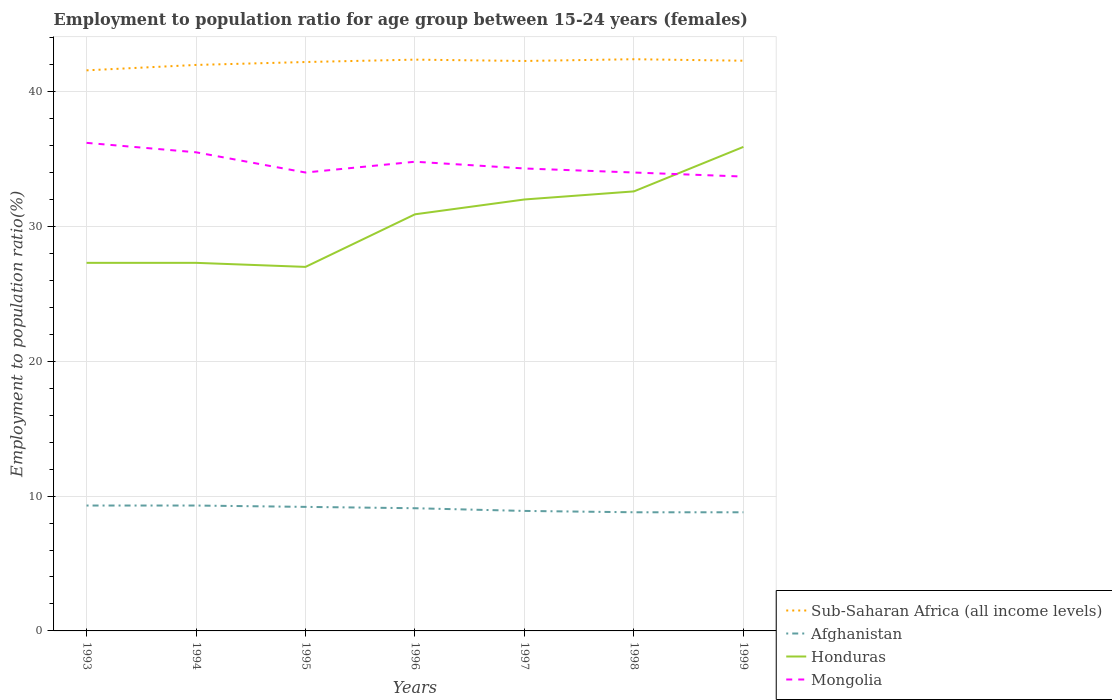How many different coloured lines are there?
Give a very brief answer. 4. Does the line corresponding to Afghanistan intersect with the line corresponding to Honduras?
Ensure brevity in your answer.  No. Is the number of lines equal to the number of legend labels?
Offer a very short reply. Yes. Across all years, what is the maximum employment to population ratio in Mongolia?
Offer a very short reply. 33.7. What is the total employment to population ratio in Mongolia in the graph?
Keep it short and to the point. 0.3. What is the difference between the highest and the lowest employment to population ratio in Honduras?
Ensure brevity in your answer.  4. Is the employment to population ratio in Sub-Saharan Africa (all income levels) strictly greater than the employment to population ratio in Mongolia over the years?
Offer a terse response. No. How many lines are there?
Give a very brief answer. 4. What is the difference between two consecutive major ticks on the Y-axis?
Ensure brevity in your answer.  10. Does the graph contain grids?
Your answer should be very brief. Yes. How are the legend labels stacked?
Your answer should be very brief. Vertical. What is the title of the graph?
Provide a short and direct response. Employment to population ratio for age group between 15-24 years (females). What is the Employment to population ratio(%) of Sub-Saharan Africa (all income levels) in 1993?
Your response must be concise. 41.58. What is the Employment to population ratio(%) of Afghanistan in 1993?
Offer a terse response. 9.3. What is the Employment to population ratio(%) of Honduras in 1993?
Keep it short and to the point. 27.3. What is the Employment to population ratio(%) of Mongolia in 1993?
Provide a short and direct response. 36.2. What is the Employment to population ratio(%) in Sub-Saharan Africa (all income levels) in 1994?
Provide a succinct answer. 41.98. What is the Employment to population ratio(%) in Afghanistan in 1994?
Offer a terse response. 9.3. What is the Employment to population ratio(%) of Honduras in 1994?
Make the answer very short. 27.3. What is the Employment to population ratio(%) in Mongolia in 1994?
Your answer should be compact. 35.5. What is the Employment to population ratio(%) of Sub-Saharan Africa (all income levels) in 1995?
Provide a succinct answer. 42.2. What is the Employment to population ratio(%) of Afghanistan in 1995?
Your answer should be very brief. 9.2. What is the Employment to population ratio(%) of Sub-Saharan Africa (all income levels) in 1996?
Provide a short and direct response. 42.37. What is the Employment to population ratio(%) in Afghanistan in 1996?
Offer a terse response. 9.1. What is the Employment to population ratio(%) in Honduras in 1996?
Your answer should be compact. 30.9. What is the Employment to population ratio(%) in Mongolia in 1996?
Keep it short and to the point. 34.8. What is the Employment to population ratio(%) of Sub-Saharan Africa (all income levels) in 1997?
Offer a terse response. 42.27. What is the Employment to population ratio(%) in Afghanistan in 1997?
Ensure brevity in your answer.  8.9. What is the Employment to population ratio(%) of Mongolia in 1997?
Make the answer very short. 34.3. What is the Employment to population ratio(%) in Sub-Saharan Africa (all income levels) in 1998?
Keep it short and to the point. 42.4. What is the Employment to population ratio(%) in Afghanistan in 1998?
Offer a terse response. 8.8. What is the Employment to population ratio(%) of Honduras in 1998?
Your answer should be compact. 32.6. What is the Employment to population ratio(%) of Sub-Saharan Africa (all income levels) in 1999?
Provide a succinct answer. 42.29. What is the Employment to population ratio(%) in Afghanistan in 1999?
Provide a short and direct response. 8.8. What is the Employment to population ratio(%) of Honduras in 1999?
Provide a succinct answer. 35.9. What is the Employment to population ratio(%) in Mongolia in 1999?
Make the answer very short. 33.7. Across all years, what is the maximum Employment to population ratio(%) in Sub-Saharan Africa (all income levels)?
Your answer should be very brief. 42.4. Across all years, what is the maximum Employment to population ratio(%) in Afghanistan?
Your answer should be compact. 9.3. Across all years, what is the maximum Employment to population ratio(%) in Honduras?
Give a very brief answer. 35.9. Across all years, what is the maximum Employment to population ratio(%) in Mongolia?
Ensure brevity in your answer.  36.2. Across all years, what is the minimum Employment to population ratio(%) of Sub-Saharan Africa (all income levels)?
Give a very brief answer. 41.58. Across all years, what is the minimum Employment to population ratio(%) of Afghanistan?
Make the answer very short. 8.8. Across all years, what is the minimum Employment to population ratio(%) in Honduras?
Provide a succinct answer. 27. Across all years, what is the minimum Employment to population ratio(%) of Mongolia?
Make the answer very short. 33.7. What is the total Employment to population ratio(%) in Sub-Saharan Africa (all income levels) in the graph?
Offer a terse response. 295.09. What is the total Employment to population ratio(%) of Afghanistan in the graph?
Provide a short and direct response. 63.4. What is the total Employment to population ratio(%) in Honduras in the graph?
Give a very brief answer. 213. What is the total Employment to population ratio(%) of Mongolia in the graph?
Give a very brief answer. 242.5. What is the difference between the Employment to population ratio(%) in Sub-Saharan Africa (all income levels) in 1993 and that in 1994?
Your answer should be very brief. -0.4. What is the difference between the Employment to population ratio(%) of Mongolia in 1993 and that in 1994?
Ensure brevity in your answer.  0.7. What is the difference between the Employment to population ratio(%) in Sub-Saharan Africa (all income levels) in 1993 and that in 1995?
Your response must be concise. -0.62. What is the difference between the Employment to population ratio(%) in Mongolia in 1993 and that in 1995?
Your answer should be compact. 2.2. What is the difference between the Employment to population ratio(%) of Sub-Saharan Africa (all income levels) in 1993 and that in 1996?
Ensure brevity in your answer.  -0.79. What is the difference between the Employment to population ratio(%) of Mongolia in 1993 and that in 1996?
Offer a terse response. 1.4. What is the difference between the Employment to population ratio(%) of Sub-Saharan Africa (all income levels) in 1993 and that in 1997?
Provide a short and direct response. -0.69. What is the difference between the Employment to population ratio(%) in Afghanistan in 1993 and that in 1997?
Make the answer very short. 0.4. What is the difference between the Employment to population ratio(%) in Honduras in 1993 and that in 1997?
Your answer should be very brief. -4.7. What is the difference between the Employment to population ratio(%) of Sub-Saharan Africa (all income levels) in 1993 and that in 1998?
Offer a very short reply. -0.82. What is the difference between the Employment to population ratio(%) in Honduras in 1993 and that in 1998?
Your response must be concise. -5.3. What is the difference between the Employment to population ratio(%) in Mongolia in 1993 and that in 1998?
Ensure brevity in your answer.  2.2. What is the difference between the Employment to population ratio(%) of Sub-Saharan Africa (all income levels) in 1993 and that in 1999?
Keep it short and to the point. -0.71. What is the difference between the Employment to population ratio(%) in Afghanistan in 1993 and that in 1999?
Your answer should be compact. 0.5. What is the difference between the Employment to population ratio(%) of Honduras in 1993 and that in 1999?
Your answer should be very brief. -8.6. What is the difference between the Employment to population ratio(%) in Sub-Saharan Africa (all income levels) in 1994 and that in 1995?
Offer a very short reply. -0.22. What is the difference between the Employment to population ratio(%) of Honduras in 1994 and that in 1995?
Offer a terse response. 0.3. What is the difference between the Employment to population ratio(%) in Sub-Saharan Africa (all income levels) in 1994 and that in 1996?
Provide a short and direct response. -0.39. What is the difference between the Employment to population ratio(%) in Sub-Saharan Africa (all income levels) in 1994 and that in 1997?
Ensure brevity in your answer.  -0.29. What is the difference between the Employment to population ratio(%) of Sub-Saharan Africa (all income levels) in 1994 and that in 1998?
Offer a terse response. -0.42. What is the difference between the Employment to population ratio(%) of Honduras in 1994 and that in 1998?
Your answer should be very brief. -5.3. What is the difference between the Employment to population ratio(%) of Mongolia in 1994 and that in 1998?
Provide a succinct answer. 1.5. What is the difference between the Employment to population ratio(%) in Sub-Saharan Africa (all income levels) in 1994 and that in 1999?
Give a very brief answer. -0.31. What is the difference between the Employment to population ratio(%) in Honduras in 1994 and that in 1999?
Your answer should be very brief. -8.6. What is the difference between the Employment to population ratio(%) of Sub-Saharan Africa (all income levels) in 1995 and that in 1996?
Give a very brief answer. -0.18. What is the difference between the Employment to population ratio(%) in Afghanistan in 1995 and that in 1996?
Provide a succinct answer. 0.1. What is the difference between the Employment to population ratio(%) of Sub-Saharan Africa (all income levels) in 1995 and that in 1997?
Your response must be concise. -0.08. What is the difference between the Employment to population ratio(%) of Afghanistan in 1995 and that in 1997?
Offer a terse response. 0.3. What is the difference between the Employment to population ratio(%) of Honduras in 1995 and that in 1997?
Ensure brevity in your answer.  -5. What is the difference between the Employment to population ratio(%) of Sub-Saharan Africa (all income levels) in 1995 and that in 1998?
Provide a succinct answer. -0.21. What is the difference between the Employment to population ratio(%) of Mongolia in 1995 and that in 1998?
Provide a short and direct response. 0. What is the difference between the Employment to population ratio(%) in Sub-Saharan Africa (all income levels) in 1995 and that in 1999?
Keep it short and to the point. -0.1. What is the difference between the Employment to population ratio(%) in Honduras in 1995 and that in 1999?
Your answer should be compact. -8.9. What is the difference between the Employment to population ratio(%) in Sub-Saharan Africa (all income levels) in 1996 and that in 1997?
Ensure brevity in your answer.  0.1. What is the difference between the Employment to population ratio(%) of Honduras in 1996 and that in 1997?
Your response must be concise. -1.1. What is the difference between the Employment to population ratio(%) in Mongolia in 1996 and that in 1997?
Ensure brevity in your answer.  0.5. What is the difference between the Employment to population ratio(%) in Sub-Saharan Africa (all income levels) in 1996 and that in 1998?
Provide a succinct answer. -0.03. What is the difference between the Employment to population ratio(%) in Honduras in 1996 and that in 1998?
Provide a succinct answer. -1.7. What is the difference between the Employment to population ratio(%) in Mongolia in 1996 and that in 1998?
Offer a very short reply. 0.8. What is the difference between the Employment to population ratio(%) of Sub-Saharan Africa (all income levels) in 1996 and that in 1999?
Provide a succinct answer. 0.08. What is the difference between the Employment to population ratio(%) in Mongolia in 1996 and that in 1999?
Ensure brevity in your answer.  1.1. What is the difference between the Employment to population ratio(%) in Sub-Saharan Africa (all income levels) in 1997 and that in 1998?
Provide a short and direct response. -0.13. What is the difference between the Employment to population ratio(%) in Afghanistan in 1997 and that in 1998?
Offer a terse response. 0.1. What is the difference between the Employment to population ratio(%) in Honduras in 1997 and that in 1998?
Your response must be concise. -0.6. What is the difference between the Employment to population ratio(%) in Mongolia in 1997 and that in 1998?
Offer a terse response. 0.3. What is the difference between the Employment to population ratio(%) in Sub-Saharan Africa (all income levels) in 1997 and that in 1999?
Offer a terse response. -0.02. What is the difference between the Employment to population ratio(%) in Sub-Saharan Africa (all income levels) in 1998 and that in 1999?
Offer a terse response. 0.11. What is the difference between the Employment to population ratio(%) of Afghanistan in 1998 and that in 1999?
Offer a terse response. 0. What is the difference between the Employment to population ratio(%) of Honduras in 1998 and that in 1999?
Make the answer very short. -3.3. What is the difference between the Employment to population ratio(%) in Mongolia in 1998 and that in 1999?
Provide a short and direct response. 0.3. What is the difference between the Employment to population ratio(%) of Sub-Saharan Africa (all income levels) in 1993 and the Employment to population ratio(%) of Afghanistan in 1994?
Make the answer very short. 32.28. What is the difference between the Employment to population ratio(%) in Sub-Saharan Africa (all income levels) in 1993 and the Employment to population ratio(%) in Honduras in 1994?
Your answer should be very brief. 14.28. What is the difference between the Employment to population ratio(%) of Sub-Saharan Africa (all income levels) in 1993 and the Employment to population ratio(%) of Mongolia in 1994?
Make the answer very short. 6.08. What is the difference between the Employment to population ratio(%) in Afghanistan in 1993 and the Employment to population ratio(%) in Mongolia in 1994?
Make the answer very short. -26.2. What is the difference between the Employment to population ratio(%) in Honduras in 1993 and the Employment to population ratio(%) in Mongolia in 1994?
Offer a very short reply. -8.2. What is the difference between the Employment to population ratio(%) in Sub-Saharan Africa (all income levels) in 1993 and the Employment to population ratio(%) in Afghanistan in 1995?
Ensure brevity in your answer.  32.38. What is the difference between the Employment to population ratio(%) in Sub-Saharan Africa (all income levels) in 1993 and the Employment to population ratio(%) in Honduras in 1995?
Offer a terse response. 14.58. What is the difference between the Employment to population ratio(%) of Sub-Saharan Africa (all income levels) in 1993 and the Employment to population ratio(%) of Mongolia in 1995?
Your answer should be compact. 7.58. What is the difference between the Employment to population ratio(%) in Afghanistan in 1993 and the Employment to population ratio(%) in Honduras in 1995?
Make the answer very short. -17.7. What is the difference between the Employment to population ratio(%) in Afghanistan in 1993 and the Employment to population ratio(%) in Mongolia in 1995?
Give a very brief answer. -24.7. What is the difference between the Employment to population ratio(%) of Honduras in 1993 and the Employment to population ratio(%) of Mongolia in 1995?
Give a very brief answer. -6.7. What is the difference between the Employment to population ratio(%) of Sub-Saharan Africa (all income levels) in 1993 and the Employment to population ratio(%) of Afghanistan in 1996?
Offer a terse response. 32.48. What is the difference between the Employment to population ratio(%) in Sub-Saharan Africa (all income levels) in 1993 and the Employment to population ratio(%) in Honduras in 1996?
Make the answer very short. 10.68. What is the difference between the Employment to population ratio(%) of Sub-Saharan Africa (all income levels) in 1993 and the Employment to population ratio(%) of Mongolia in 1996?
Ensure brevity in your answer.  6.78. What is the difference between the Employment to population ratio(%) in Afghanistan in 1993 and the Employment to population ratio(%) in Honduras in 1996?
Offer a terse response. -21.6. What is the difference between the Employment to population ratio(%) in Afghanistan in 1993 and the Employment to population ratio(%) in Mongolia in 1996?
Ensure brevity in your answer.  -25.5. What is the difference between the Employment to population ratio(%) in Sub-Saharan Africa (all income levels) in 1993 and the Employment to population ratio(%) in Afghanistan in 1997?
Ensure brevity in your answer.  32.68. What is the difference between the Employment to population ratio(%) in Sub-Saharan Africa (all income levels) in 1993 and the Employment to population ratio(%) in Honduras in 1997?
Provide a short and direct response. 9.58. What is the difference between the Employment to population ratio(%) in Sub-Saharan Africa (all income levels) in 1993 and the Employment to population ratio(%) in Mongolia in 1997?
Your response must be concise. 7.28. What is the difference between the Employment to population ratio(%) of Afghanistan in 1993 and the Employment to population ratio(%) of Honduras in 1997?
Offer a very short reply. -22.7. What is the difference between the Employment to population ratio(%) of Afghanistan in 1993 and the Employment to population ratio(%) of Mongolia in 1997?
Give a very brief answer. -25. What is the difference between the Employment to population ratio(%) of Honduras in 1993 and the Employment to population ratio(%) of Mongolia in 1997?
Offer a very short reply. -7. What is the difference between the Employment to population ratio(%) of Sub-Saharan Africa (all income levels) in 1993 and the Employment to population ratio(%) of Afghanistan in 1998?
Your response must be concise. 32.78. What is the difference between the Employment to population ratio(%) in Sub-Saharan Africa (all income levels) in 1993 and the Employment to population ratio(%) in Honduras in 1998?
Offer a very short reply. 8.98. What is the difference between the Employment to population ratio(%) of Sub-Saharan Africa (all income levels) in 1993 and the Employment to population ratio(%) of Mongolia in 1998?
Give a very brief answer. 7.58. What is the difference between the Employment to population ratio(%) in Afghanistan in 1993 and the Employment to population ratio(%) in Honduras in 1998?
Provide a succinct answer. -23.3. What is the difference between the Employment to population ratio(%) in Afghanistan in 1993 and the Employment to population ratio(%) in Mongolia in 1998?
Your answer should be very brief. -24.7. What is the difference between the Employment to population ratio(%) of Honduras in 1993 and the Employment to population ratio(%) of Mongolia in 1998?
Offer a very short reply. -6.7. What is the difference between the Employment to population ratio(%) of Sub-Saharan Africa (all income levels) in 1993 and the Employment to population ratio(%) of Afghanistan in 1999?
Offer a very short reply. 32.78. What is the difference between the Employment to population ratio(%) in Sub-Saharan Africa (all income levels) in 1993 and the Employment to population ratio(%) in Honduras in 1999?
Make the answer very short. 5.68. What is the difference between the Employment to population ratio(%) of Sub-Saharan Africa (all income levels) in 1993 and the Employment to population ratio(%) of Mongolia in 1999?
Offer a very short reply. 7.88. What is the difference between the Employment to population ratio(%) of Afghanistan in 1993 and the Employment to population ratio(%) of Honduras in 1999?
Your answer should be compact. -26.6. What is the difference between the Employment to population ratio(%) of Afghanistan in 1993 and the Employment to population ratio(%) of Mongolia in 1999?
Offer a terse response. -24.4. What is the difference between the Employment to population ratio(%) of Sub-Saharan Africa (all income levels) in 1994 and the Employment to population ratio(%) of Afghanistan in 1995?
Offer a very short reply. 32.78. What is the difference between the Employment to population ratio(%) of Sub-Saharan Africa (all income levels) in 1994 and the Employment to population ratio(%) of Honduras in 1995?
Give a very brief answer. 14.98. What is the difference between the Employment to population ratio(%) in Sub-Saharan Africa (all income levels) in 1994 and the Employment to population ratio(%) in Mongolia in 1995?
Provide a succinct answer. 7.98. What is the difference between the Employment to population ratio(%) of Afghanistan in 1994 and the Employment to population ratio(%) of Honduras in 1995?
Your response must be concise. -17.7. What is the difference between the Employment to population ratio(%) of Afghanistan in 1994 and the Employment to population ratio(%) of Mongolia in 1995?
Ensure brevity in your answer.  -24.7. What is the difference between the Employment to population ratio(%) of Sub-Saharan Africa (all income levels) in 1994 and the Employment to population ratio(%) of Afghanistan in 1996?
Provide a succinct answer. 32.88. What is the difference between the Employment to population ratio(%) of Sub-Saharan Africa (all income levels) in 1994 and the Employment to population ratio(%) of Honduras in 1996?
Your response must be concise. 11.08. What is the difference between the Employment to population ratio(%) in Sub-Saharan Africa (all income levels) in 1994 and the Employment to population ratio(%) in Mongolia in 1996?
Offer a very short reply. 7.18. What is the difference between the Employment to population ratio(%) of Afghanistan in 1994 and the Employment to population ratio(%) of Honduras in 1996?
Your response must be concise. -21.6. What is the difference between the Employment to population ratio(%) of Afghanistan in 1994 and the Employment to population ratio(%) of Mongolia in 1996?
Offer a very short reply. -25.5. What is the difference between the Employment to population ratio(%) in Honduras in 1994 and the Employment to population ratio(%) in Mongolia in 1996?
Provide a succinct answer. -7.5. What is the difference between the Employment to population ratio(%) of Sub-Saharan Africa (all income levels) in 1994 and the Employment to population ratio(%) of Afghanistan in 1997?
Make the answer very short. 33.08. What is the difference between the Employment to population ratio(%) of Sub-Saharan Africa (all income levels) in 1994 and the Employment to population ratio(%) of Honduras in 1997?
Offer a terse response. 9.98. What is the difference between the Employment to population ratio(%) of Sub-Saharan Africa (all income levels) in 1994 and the Employment to population ratio(%) of Mongolia in 1997?
Ensure brevity in your answer.  7.68. What is the difference between the Employment to population ratio(%) in Afghanistan in 1994 and the Employment to population ratio(%) in Honduras in 1997?
Your answer should be very brief. -22.7. What is the difference between the Employment to population ratio(%) in Afghanistan in 1994 and the Employment to population ratio(%) in Mongolia in 1997?
Provide a succinct answer. -25. What is the difference between the Employment to population ratio(%) of Honduras in 1994 and the Employment to population ratio(%) of Mongolia in 1997?
Your response must be concise. -7. What is the difference between the Employment to population ratio(%) in Sub-Saharan Africa (all income levels) in 1994 and the Employment to population ratio(%) in Afghanistan in 1998?
Your response must be concise. 33.18. What is the difference between the Employment to population ratio(%) of Sub-Saharan Africa (all income levels) in 1994 and the Employment to population ratio(%) of Honduras in 1998?
Your answer should be compact. 9.38. What is the difference between the Employment to population ratio(%) in Sub-Saharan Africa (all income levels) in 1994 and the Employment to population ratio(%) in Mongolia in 1998?
Your response must be concise. 7.98. What is the difference between the Employment to population ratio(%) of Afghanistan in 1994 and the Employment to population ratio(%) of Honduras in 1998?
Your answer should be compact. -23.3. What is the difference between the Employment to population ratio(%) of Afghanistan in 1994 and the Employment to population ratio(%) of Mongolia in 1998?
Provide a short and direct response. -24.7. What is the difference between the Employment to population ratio(%) of Honduras in 1994 and the Employment to population ratio(%) of Mongolia in 1998?
Provide a short and direct response. -6.7. What is the difference between the Employment to population ratio(%) of Sub-Saharan Africa (all income levels) in 1994 and the Employment to population ratio(%) of Afghanistan in 1999?
Make the answer very short. 33.18. What is the difference between the Employment to population ratio(%) of Sub-Saharan Africa (all income levels) in 1994 and the Employment to population ratio(%) of Honduras in 1999?
Ensure brevity in your answer.  6.08. What is the difference between the Employment to population ratio(%) in Sub-Saharan Africa (all income levels) in 1994 and the Employment to population ratio(%) in Mongolia in 1999?
Your response must be concise. 8.28. What is the difference between the Employment to population ratio(%) of Afghanistan in 1994 and the Employment to population ratio(%) of Honduras in 1999?
Keep it short and to the point. -26.6. What is the difference between the Employment to population ratio(%) of Afghanistan in 1994 and the Employment to population ratio(%) of Mongolia in 1999?
Provide a short and direct response. -24.4. What is the difference between the Employment to population ratio(%) of Honduras in 1994 and the Employment to population ratio(%) of Mongolia in 1999?
Offer a very short reply. -6.4. What is the difference between the Employment to population ratio(%) of Sub-Saharan Africa (all income levels) in 1995 and the Employment to population ratio(%) of Afghanistan in 1996?
Offer a very short reply. 33.1. What is the difference between the Employment to population ratio(%) in Sub-Saharan Africa (all income levels) in 1995 and the Employment to population ratio(%) in Honduras in 1996?
Your answer should be compact. 11.3. What is the difference between the Employment to population ratio(%) in Sub-Saharan Africa (all income levels) in 1995 and the Employment to population ratio(%) in Mongolia in 1996?
Give a very brief answer. 7.4. What is the difference between the Employment to population ratio(%) of Afghanistan in 1995 and the Employment to population ratio(%) of Honduras in 1996?
Your response must be concise. -21.7. What is the difference between the Employment to population ratio(%) of Afghanistan in 1995 and the Employment to population ratio(%) of Mongolia in 1996?
Provide a succinct answer. -25.6. What is the difference between the Employment to population ratio(%) in Sub-Saharan Africa (all income levels) in 1995 and the Employment to population ratio(%) in Afghanistan in 1997?
Provide a succinct answer. 33.3. What is the difference between the Employment to population ratio(%) in Sub-Saharan Africa (all income levels) in 1995 and the Employment to population ratio(%) in Honduras in 1997?
Ensure brevity in your answer.  10.2. What is the difference between the Employment to population ratio(%) of Sub-Saharan Africa (all income levels) in 1995 and the Employment to population ratio(%) of Mongolia in 1997?
Offer a very short reply. 7.9. What is the difference between the Employment to population ratio(%) in Afghanistan in 1995 and the Employment to population ratio(%) in Honduras in 1997?
Make the answer very short. -22.8. What is the difference between the Employment to population ratio(%) in Afghanistan in 1995 and the Employment to population ratio(%) in Mongolia in 1997?
Provide a succinct answer. -25.1. What is the difference between the Employment to population ratio(%) in Sub-Saharan Africa (all income levels) in 1995 and the Employment to population ratio(%) in Afghanistan in 1998?
Give a very brief answer. 33.4. What is the difference between the Employment to population ratio(%) in Sub-Saharan Africa (all income levels) in 1995 and the Employment to population ratio(%) in Honduras in 1998?
Your answer should be compact. 9.6. What is the difference between the Employment to population ratio(%) in Sub-Saharan Africa (all income levels) in 1995 and the Employment to population ratio(%) in Mongolia in 1998?
Provide a short and direct response. 8.2. What is the difference between the Employment to population ratio(%) in Afghanistan in 1995 and the Employment to population ratio(%) in Honduras in 1998?
Offer a terse response. -23.4. What is the difference between the Employment to population ratio(%) in Afghanistan in 1995 and the Employment to population ratio(%) in Mongolia in 1998?
Make the answer very short. -24.8. What is the difference between the Employment to population ratio(%) in Sub-Saharan Africa (all income levels) in 1995 and the Employment to population ratio(%) in Afghanistan in 1999?
Your answer should be compact. 33.4. What is the difference between the Employment to population ratio(%) of Sub-Saharan Africa (all income levels) in 1995 and the Employment to population ratio(%) of Honduras in 1999?
Provide a short and direct response. 6.3. What is the difference between the Employment to population ratio(%) of Sub-Saharan Africa (all income levels) in 1995 and the Employment to population ratio(%) of Mongolia in 1999?
Offer a terse response. 8.5. What is the difference between the Employment to population ratio(%) in Afghanistan in 1995 and the Employment to population ratio(%) in Honduras in 1999?
Your answer should be very brief. -26.7. What is the difference between the Employment to population ratio(%) in Afghanistan in 1995 and the Employment to population ratio(%) in Mongolia in 1999?
Your answer should be very brief. -24.5. What is the difference between the Employment to population ratio(%) in Honduras in 1995 and the Employment to population ratio(%) in Mongolia in 1999?
Your response must be concise. -6.7. What is the difference between the Employment to population ratio(%) in Sub-Saharan Africa (all income levels) in 1996 and the Employment to population ratio(%) in Afghanistan in 1997?
Your answer should be very brief. 33.47. What is the difference between the Employment to population ratio(%) of Sub-Saharan Africa (all income levels) in 1996 and the Employment to population ratio(%) of Honduras in 1997?
Keep it short and to the point. 10.37. What is the difference between the Employment to population ratio(%) in Sub-Saharan Africa (all income levels) in 1996 and the Employment to population ratio(%) in Mongolia in 1997?
Ensure brevity in your answer.  8.07. What is the difference between the Employment to population ratio(%) in Afghanistan in 1996 and the Employment to population ratio(%) in Honduras in 1997?
Your answer should be very brief. -22.9. What is the difference between the Employment to population ratio(%) of Afghanistan in 1996 and the Employment to population ratio(%) of Mongolia in 1997?
Your answer should be compact. -25.2. What is the difference between the Employment to population ratio(%) in Sub-Saharan Africa (all income levels) in 1996 and the Employment to population ratio(%) in Afghanistan in 1998?
Offer a very short reply. 33.57. What is the difference between the Employment to population ratio(%) in Sub-Saharan Africa (all income levels) in 1996 and the Employment to population ratio(%) in Honduras in 1998?
Your response must be concise. 9.77. What is the difference between the Employment to population ratio(%) in Sub-Saharan Africa (all income levels) in 1996 and the Employment to population ratio(%) in Mongolia in 1998?
Your answer should be very brief. 8.37. What is the difference between the Employment to population ratio(%) in Afghanistan in 1996 and the Employment to population ratio(%) in Honduras in 1998?
Your answer should be compact. -23.5. What is the difference between the Employment to population ratio(%) in Afghanistan in 1996 and the Employment to population ratio(%) in Mongolia in 1998?
Your response must be concise. -24.9. What is the difference between the Employment to population ratio(%) in Sub-Saharan Africa (all income levels) in 1996 and the Employment to population ratio(%) in Afghanistan in 1999?
Your response must be concise. 33.57. What is the difference between the Employment to population ratio(%) in Sub-Saharan Africa (all income levels) in 1996 and the Employment to population ratio(%) in Honduras in 1999?
Your response must be concise. 6.47. What is the difference between the Employment to population ratio(%) in Sub-Saharan Africa (all income levels) in 1996 and the Employment to population ratio(%) in Mongolia in 1999?
Keep it short and to the point. 8.67. What is the difference between the Employment to population ratio(%) of Afghanistan in 1996 and the Employment to population ratio(%) of Honduras in 1999?
Your response must be concise. -26.8. What is the difference between the Employment to population ratio(%) in Afghanistan in 1996 and the Employment to population ratio(%) in Mongolia in 1999?
Your answer should be very brief. -24.6. What is the difference between the Employment to population ratio(%) of Sub-Saharan Africa (all income levels) in 1997 and the Employment to population ratio(%) of Afghanistan in 1998?
Offer a terse response. 33.47. What is the difference between the Employment to population ratio(%) in Sub-Saharan Africa (all income levels) in 1997 and the Employment to population ratio(%) in Honduras in 1998?
Offer a very short reply. 9.67. What is the difference between the Employment to population ratio(%) in Sub-Saharan Africa (all income levels) in 1997 and the Employment to population ratio(%) in Mongolia in 1998?
Make the answer very short. 8.27. What is the difference between the Employment to population ratio(%) in Afghanistan in 1997 and the Employment to population ratio(%) in Honduras in 1998?
Provide a succinct answer. -23.7. What is the difference between the Employment to population ratio(%) in Afghanistan in 1997 and the Employment to population ratio(%) in Mongolia in 1998?
Your response must be concise. -25.1. What is the difference between the Employment to population ratio(%) in Honduras in 1997 and the Employment to population ratio(%) in Mongolia in 1998?
Make the answer very short. -2. What is the difference between the Employment to population ratio(%) in Sub-Saharan Africa (all income levels) in 1997 and the Employment to population ratio(%) in Afghanistan in 1999?
Provide a succinct answer. 33.47. What is the difference between the Employment to population ratio(%) of Sub-Saharan Africa (all income levels) in 1997 and the Employment to population ratio(%) of Honduras in 1999?
Your answer should be compact. 6.37. What is the difference between the Employment to population ratio(%) of Sub-Saharan Africa (all income levels) in 1997 and the Employment to population ratio(%) of Mongolia in 1999?
Give a very brief answer. 8.57. What is the difference between the Employment to population ratio(%) of Afghanistan in 1997 and the Employment to population ratio(%) of Mongolia in 1999?
Your answer should be very brief. -24.8. What is the difference between the Employment to population ratio(%) in Sub-Saharan Africa (all income levels) in 1998 and the Employment to population ratio(%) in Afghanistan in 1999?
Provide a short and direct response. 33.6. What is the difference between the Employment to population ratio(%) of Sub-Saharan Africa (all income levels) in 1998 and the Employment to population ratio(%) of Honduras in 1999?
Your response must be concise. 6.5. What is the difference between the Employment to population ratio(%) of Sub-Saharan Africa (all income levels) in 1998 and the Employment to population ratio(%) of Mongolia in 1999?
Make the answer very short. 8.7. What is the difference between the Employment to population ratio(%) of Afghanistan in 1998 and the Employment to population ratio(%) of Honduras in 1999?
Your answer should be compact. -27.1. What is the difference between the Employment to population ratio(%) in Afghanistan in 1998 and the Employment to population ratio(%) in Mongolia in 1999?
Provide a succinct answer. -24.9. What is the difference between the Employment to population ratio(%) in Honduras in 1998 and the Employment to population ratio(%) in Mongolia in 1999?
Give a very brief answer. -1.1. What is the average Employment to population ratio(%) of Sub-Saharan Africa (all income levels) per year?
Make the answer very short. 42.16. What is the average Employment to population ratio(%) of Afghanistan per year?
Your response must be concise. 9.06. What is the average Employment to population ratio(%) of Honduras per year?
Ensure brevity in your answer.  30.43. What is the average Employment to population ratio(%) in Mongolia per year?
Your answer should be compact. 34.64. In the year 1993, what is the difference between the Employment to population ratio(%) in Sub-Saharan Africa (all income levels) and Employment to population ratio(%) in Afghanistan?
Make the answer very short. 32.28. In the year 1993, what is the difference between the Employment to population ratio(%) of Sub-Saharan Africa (all income levels) and Employment to population ratio(%) of Honduras?
Your response must be concise. 14.28. In the year 1993, what is the difference between the Employment to population ratio(%) in Sub-Saharan Africa (all income levels) and Employment to population ratio(%) in Mongolia?
Your answer should be very brief. 5.38. In the year 1993, what is the difference between the Employment to population ratio(%) of Afghanistan and Employment to population ratio(%) of Mongolia?
Offer a very short reply. -26.9. In the year 1994, what is the difference between the Employment to population ratio(%) of Sub-Saharan Africa (all income levels) and Employment to population ratio(%) of Afghanistan?
Keep it short and to the point. 32.68. In the year 1994, what is the difference between the Employment to population ratio(%) in Sub-Saharan Africa (all income levels) and Employment to population ratio(%) in Honduras?
Ensure brevity in your answer.  14.68. In the year 1994, what is the difference between the Employment to population ratio(%) in Sub-Saharan Africa (all income levels) and Employment to population ratio(%) in Mongolia?
Ensure brevity in your answer.  6.48. In the year 1994, what is the difference between the Employment to population ratio(%) in Afghanistan and Employment to population ratio(%) in Honduras?
Ensure brevity in your answer.  -18. In the year 1994, what is the difference between the Employment to population ratio(%) of Afghanistan and Employment to population ratio(%) of Mongolia?
Offer a very short reply. -26.2. In the year 1994, what is the difference between the Employment to population ratio(%) in Honduras and Employment to population ratio(%) in Mongolia?
Offer a terse response. -8.2. In the year 1995, what is the difference between the Employment to population ratio(%) in Sub-Saharan Africa (all income levels) and Employment to population ratio(%) in Afghanistan?
Your answer should be compact. 33. In the year 1995, what is the difference between the Employment to population ratio(%) of Sub-Saharan Africa (all income levels) and Employment to population ratio(%) of Honduras?
Give a very brief answer. 15.2. In the year 1995, what is the difference between the Employment to population ratio(%) in Sub-Saharan Africa (all income levels) and Employment to population ratio(%) in Mongolia?
Your answer should be compact. 8.2. In the year 1995, what is the difference between the Employment to population ratio(%) in Afghanistan and Employment to population ratio(%) in Honduras?
Your answer should be very brief. -17.8. In the year 1995, what is the difference between the Employment to population ratio(%) in Afghanistan and Employment to population ratio(%) in Mongolia?
Provide a short and direct response. -24.8. In the year 1996, what is the difference between the Employment to population ratio(%) in Sub-Saharan Africa (all income levels) and Employment to population ratio(%) in Afghanistan?
Ensure brevity in your answer.  33.27. In the year 1996, what is the difference between the Employment to population ratio(%) of Sub-Saharan Africa (all income levels) and Employment to population ratio(%) of Honduras?
Give a very brief answer. 11.47. In the year 1996, what is the difference between the Employment to population ratio(%) of Sub-Saharan Africa (all income levels) and Employment to population ratio(%) of Mongolia?
Give a very brief answer. 7.57. In the year 1996, what is the difference between the Employment to population ratio(%) in Afghanistan and Employment to population ratio(%) in Honduras?
Your response must be concise. -21.8. In the year 1996, what is the difference between the Employment to population ratio(%) of Afghanistan and Employment to population ratio(%) of Mongolia?
Your answer should be compact. -25.7. In the year 1997, what is the difference between the Employment to population ratio(%) in Sub-Saharan Africa (all income levels) and Employment to population ratio(%) in Afghanistan?
Provide a succinct answer. 33.37. In the year 1997, what is the difference between the Employment to population ratio(%) in Sub-Saharan Africa (all income levels) and Employment to population ratio(%) in Honduras?
Keep it short and to the point. 10.27. In the year 1997, what is the difference between the Employment to population ratio(%) of Sub-Saharan Africa (all income levels) and Employment to population ratio(%) of Mongolia?
Give a very brief answer. 7.97. In the year 1997, what is the difference between the Employment to population ratio(%) of Afghanistan and Employment to population ratio(%) of Honduras?
Your response must be concise. -23.1. In the year 1997, what is the difference between the Employment to population ratio(%) in Afghanistan and Employment to population ratio(%) in Mongolia?
Offer a very short reply. -25.4. In the year 1997, what is the difference between the Employment to population ratio(%) of Honduras and Employment to population ratio(%) of Mongolia?
Your answer should be compact. -2.3. In the year 1998, what is the difference between the Employment to population ratio(%) in Sub-Saharan Africa (all income levels) and Employment to population ratio(%) in Afghanistan?
Give a very brief answer. 33.6. In the year 1998, what is the difference between the Employment to population ratio(%) of Sub-Saharan Africa (all income levels) and Employment to population ratio(%) of Honduras?
Make the answer very short. 9.8. In the year 1998, what is the difference between the Employment to population ratio(%) in Sub-Saharan Africa (all income levels) and Employment to population ratio(%) in Mongolia?
Your answer should be very brief. 8.4. In the year 1998, what is the difference between the Employment to population ratio(%) of Afghanistan and Employment to population ratio(%) of Honduras?
Your answer should be compact. -23.8. In the year 1998, what is the difference between the Employment to population ratio(%) in Afghanistan and Employment to population ratio(%) in Mongolia?
Ensure brevity in your answer.  -25.2. In the year 1998, what is the difference between the Employment to population ratio(%) in Honduras and Employment to population ratio(%) in Mongolia?
Keep it short and to the point. -1.4. In the year 1999, what is the difference between the Employment to population ratio(%) in Sub-Saharan Africa (all income levels) and Employment to population ratio(%) in Afghanistan?
Your answer should be compact. 33.49. In the year 1999, what is the difference between the Employment to population ratio(%) of Sub-Saharan Africa (all income levels) and Employment to population ratio(%) of Honduras?
Ensure brevity in your answer.  6.39. In the year 1999, what is the difference between the Employment to population ratio(%) in Sub-Saharan Africa (all income levels) and Employment to population ratio(%) in Mongolia?
Give a very brief answer. 8.59. In the year 1999, what is the difference between the Employment to population ratio(%) in Afghanistan and Employment to population ratio(%) in Honduras?
Your response must be concise. -27.1. In the year 1999, what is the difference between the Employment to population ratio(%) of Afghanistan and Employment to population ratio(%) of Mongolia?
Ensure brevity in your answer.  -24.9. In the year 1999, what is the difference between the Employment to population ratio(%) in Honduras and Employment to population ratio(%) in Mongolia?
Your answer should be compact. 2.2. What is the ratio of the Employment to population ratio(%) in Mongolia in 1993 to that in 1994?
Keep it short and to the point. 1.02. What is the ratio of the Employment to population ratio(%) in Sub-Saharan Africa (all income levels) in 1993 to that in 1995?
Give a very brief answer. 0.99. What is the ratio of the Employment to population ratio(%) in Afghanistan in 1993 to that in 1995?
Ensure brevity in your answer.  1.01. What is the ratio of the Employment to population ratio(%) in Honduras in 1993 to that in 1995?
Provide a short and direct response. 1.01. What is the ratio of the Employment to population ratio(%) in Mongolia in 1993 to that in 1995?
Offer a very short reply. 1.06. What is the ratio of the Employment to population ratio(%) of Sub-Saharan Africa (all income levels) in 1993 to that in 1996?
Offer a terse response. 0.98. What is the ratio of the Employment to population ratio(%) in Afghanistan in 1993 to that in 1996?
Your response must be concise. 1.02. What is the ratio of the Employment to population ratio(%) in Honduras in 1993 to that in 1996?
Offer a very short reply. 0.88. What is the ratio of the Employment to population ratio(%) in Mongolia in 1993 to that in 1996?
Your answer should be very brief. 1.04. What is the ratio of the Employment to population ratio(%) of Sub-Saharan Africa (all income levels) in 1993 to that in 1997?
Your answer should be compact. 0.98. What is the ratio of the Employment to population ratio(%) in Afghanistan in 1993 to that in 1997?
Offer a very short reply. 1.04. What is the ratio of the Employment to population ratio(%) of Honduras in 1993 to that in 1997?
Ensure brevity in your answer.  0.85. What is the ratio of the Employment to population ratio(%) of Mongolia in 1993 to that in 1997?
Your answer should be very brief. 1.06. What is the ratio of the Employment to population ratio(%) of Sub-Saharan Africa (all income levels) in 1993 to that in 1998?
Your answer should be compact. 0.98. What is the ratio of the Employment to population ratio(%) in Afghanistan in 1993 to that in 1998?
Provide a short and direct response. 1.06. What is the ratio of the Employment to population ratio(%) of Honduras in 1993 to that in 1998?
Ensure brevity in your answer.  0.84. What is the ratio of the Employment to population ratio(%) of Mongolia in 1993 to that in 1998?
Keep it short and to the point. 1.06. What is the ratio of the Employment to population ratio(%) of Sub-Saharan Africa (all income levels) in 1993 to that in 1999?
Offer a terse response. 0.98. What is the ratio of the Employment to population ratio(%) in Afghanistan in 1993 to that in 1999?
Your answer should be very brief. 1.06. What is the ratio of the Employment to population ratio(%) in Honduras in 1993 to that in 1999?
Ensure brevity in your answer.  0.76. What is the ratio of the Employment to population ratio(%) of Mongolia in 1993 to that in 1999?
Your response must be concise. 1.07. What is the ratio of the Employment to population ratio(%) of Afghanistan in 1994 to that in 1995?
Make the answer very short. 1.01. What is the ratio of the Employment to population ratio(%) in Honduras in 1994 to that in 1995?
Offer a very short reply. 1.01. What is the ratio of the Employment to population ratio(%) in Mongolia in 1994 to that in 1995?
Ensure brevity in your answer.  1.04. What is the ratio of the Employment to population ratio(%) in Sub-Saharan Africa (all income levels) in 1994 to that in 1996?
Your response must be concise. 0.99. What is the ratio of the Employment to population ratio(%) of Honduras in 1994 to that in 1996?
Give a very brief answer. 0.88. What is the ratio of the Employment to population ratio(%) of Mongolia in 1994 to that in 1996?
Provide a succinct answer. 1.02. What is the ratio of the Employment to population ratio(%) of Afghanistan in 1994 to that in 1997?
Ensure brevity in your answer.  1.04. What is the ratio of the Employment to population ratio(%) in Honduras in 1994 to that in 1997?
Give a very brief answer. 0.85. What is the ratio of the Employment to population ratio(%) in Mongolia in 1994 to that in 1997?
Keep it short and to the point. 1.03. What is the ratio of the Employment to population ratio(%) in Sub-Saharan Africa (all income levels) in 1994 to that in 1998?
Keep it short and to the point. 0.99. What is the ratio of the Employment to population ratio(%) of Afghanistan in 1994 to that in 1998?
Provide a short and direct response. 1.06. What is the ratio of the Employment to population ratio(%) in Honduras in 1994 to that in 1998?
Provide a succinct answer. 0.84. What is the ratio of the Employment to population ratio(%) of Mongolia in 1994 to that in 1998?
Provide a succinct answer. 1.04. What is the ratio of the Employment to population ratio(%) in Afghanistan in 1994 to that in 1999?
Keep it short and to the point. 1.06. What is the ratio of the Employment to population ratio(%) in Honduras in 1994 to that in 1999?
Offer a terse response. 0.76. What is the ratio of the Employment to population ratio(%) of Mongolia in 1994 to that in 1999?
Offer a terse response. 1.05. What is the ratio of the Employment to population ratio(%) in Sub-Saharan Africa (all income levels) in 1995 to that in 1996?
Provide a succinct answer. 1. What is the ratio of the Employment to population ratio(%) in Afghanistan in 1995 to that in 1996?
Offer a very short reply. 1.01. What is the ratio of the Employment to population ratio(%) of Honduras in 1995 to that in 1996?
Offer a very short reply. 0.87. What is the ratio of the Employment to population ratio(%) of Mongolia in 1995 to that in 1996?
Your answer should be very brief. 0.98. What is the ratio of the Employment to population ratio(%) in Afghanistan in 1995 to that in 1997?
Provide a short and direct response. 1.03. What is the ratio of the Employment to population ratio(%) in Honduras in 1995 to that in 1997?
Provide a succinct answer. 0.84. What is the ratio of the Employment to population ratio(%) in Sub-Saharan Africa (all income levels) in 1995 to that in 1998?
Offer a very short reply. 1. What is the ratio of the Employment to population ratio(%) in Afghanistan in 1995 to that in 1998?
Provide a succinct answer. 1.05. What is the ratio of the Employment to population ratio(%) of Honduras in 1995 to that in 1998?
Make the answer very short. 0.83. What is the ratio of the Employment to population ratio(%) of Afghanistan in 1995 to that in 1999?
Your answer should be very brief. 1.05. What is the ratio of the Employment to population ratio(%) in Honduras in 1995 to that in 1999?
Offer a terse response. 0.75. What is the ratio of the Employment to population ratio(%) in Mongolia in 1995 to that in 1999?
Offer a terse response. 1.01. What is the ratio of the Employment to population ratio(%) in Afghanistan in 1996 to that in 1997?
Keep it short and to the point. 1.02. What is the ratio of the Employment to population ratio(%) of Honduras in 1996 to that in 1997?
Provide a short and direct response. 0.97. What is the ratio of the Employment to population ratio(%) in Mongolia in 1996 to that in 1997?
Offer a terse response. 1.01. What is the ratio of the Employment to population ratio(%) of Afghanistan in 1996 to that in 1998?
Your answer should be compact. 1.03. What is the ratio of the Employment to population ratio(%) of Honduras in 1996 to that in 1998?
Offer a terse response. 0.95. What is the ratio of the Employment to population ratio(%) of Mongolia in 1996 to that in 1998?
Make the answer very short. 1.02. What is the ratio of the Employment to population ratio(%) in Afghanistan in 1996 to that in 1999?
Offer a terse response. 1.03. What is the ratio of the Employment to population ratio(%) of Honduras in 1996 to that in 1999?
Keep it short and to the point. 0.86. What is the ratio of the Employment to population ratio(%) of Mongolia in 1996 to that in 1999?
Offer a terse response. 1.03. What is the ratio of the Employment to population ratio(%) in Sub-Saharan Africa (all income levels) in 1997 to that in 1998?
Your answer should be very brief. 1. What is the ratio of the Employment to population ratio(%) of Afghanistan in 1997 to that in 1998?
Ensure brevity in your answer.  1.01. What is the ratio of the Employment to population ratio(%) of Honduras in 1997 to that in 1998?
Your answer should be compact. 0.98. What is the ratio of the Employment to population ratio(%) in Mongolia in 1997 to that in 1998?
Make the answer very short. 1.01. What is the ratio of the Employment to population ratio(%) of Afghanistan in 1997 to that in 1999?
Ensure brevity in your answer.  1.01. What is the ratio of the Employment to population ratio(%) of Honduras in 1997 to that in 1999?
Provide a succinct answer. 0.89. What is the ratio of the Employment to population ratio(%) in Mongolia in 1997 to that in 1999?
Ensure brevity in your answer.  1.02. What is the ratio of the Employment to population ratio(%) of Sub-Saharan Africa (all income levels) in 1998 to that in 1999?
Offer a very short reply. 1. What is the ratio of the Employment to population ratio(%) in Afghanistan in 1998 to that in 1999?
Make the answer very short. 1. What is the ratio of the Employment to population ratio(%) of Honduras in 1998 to that in 1999?
Keep it short and to the point. 0.91. What is the ratio of the Employment to population ratio(%) of Mongolia in 1998 to that in 1999?
Offer a very short reply. 1.01. What is the difference between the highest and the second highest Employment to population ratio(%) of Sub-Saharan Africa (all income levels)?
Your answer should be very brief. 0.03. What is the difference between the highest and the second highest Employment to population ratio(%) of Honduras?
Offer a terse response. 3.3. What is the difference between the highest and the lowest Employment to population ratio(%) in Sub-Saharan Africa (all income levels)?
Offer a very short reply. 0.82. What is the difference between the highest and the lowest Employment to population ratio(%) in Honduras?
Ensure brevity in your answer.  8.9. 